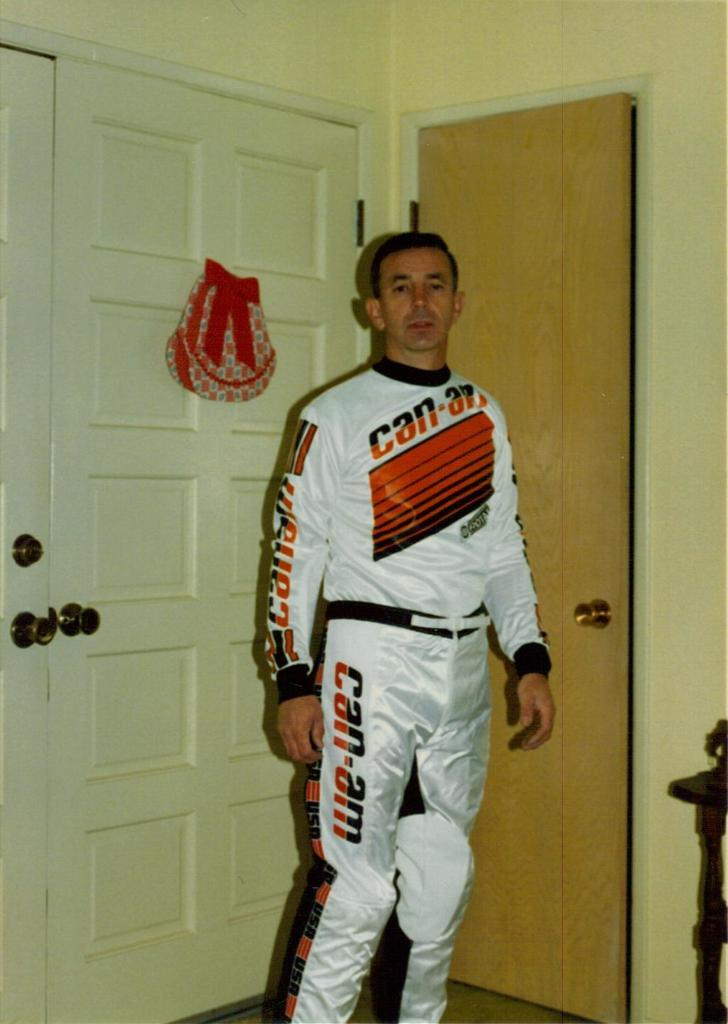<image>
Provide a brief description of the given image. a man that is posing with a can am shirt on 